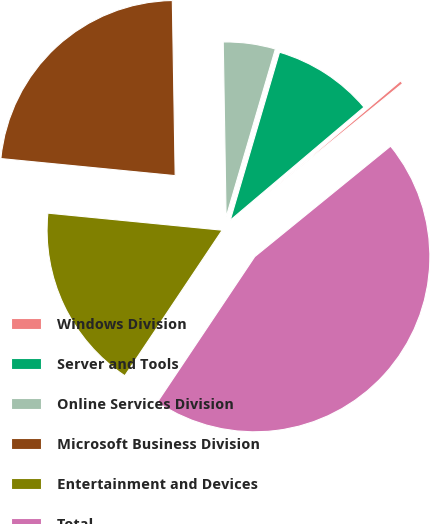Convert chart to OTSL. <chart><loc_0><loc_0><loc_500><loc_500><pie_chart><fcel>Windows Division<fcel>Server and Tools<fcel>Online Services Division<fcel>Microsoft Business Division<fcel>Entertainment and Devices<fcel>Total<nl><fcel>0.3%<fcel>9.29%<fcel>4.8%<fcel>23.19%<fcel>17.17%<fcel>45.26%<nl></chart> 